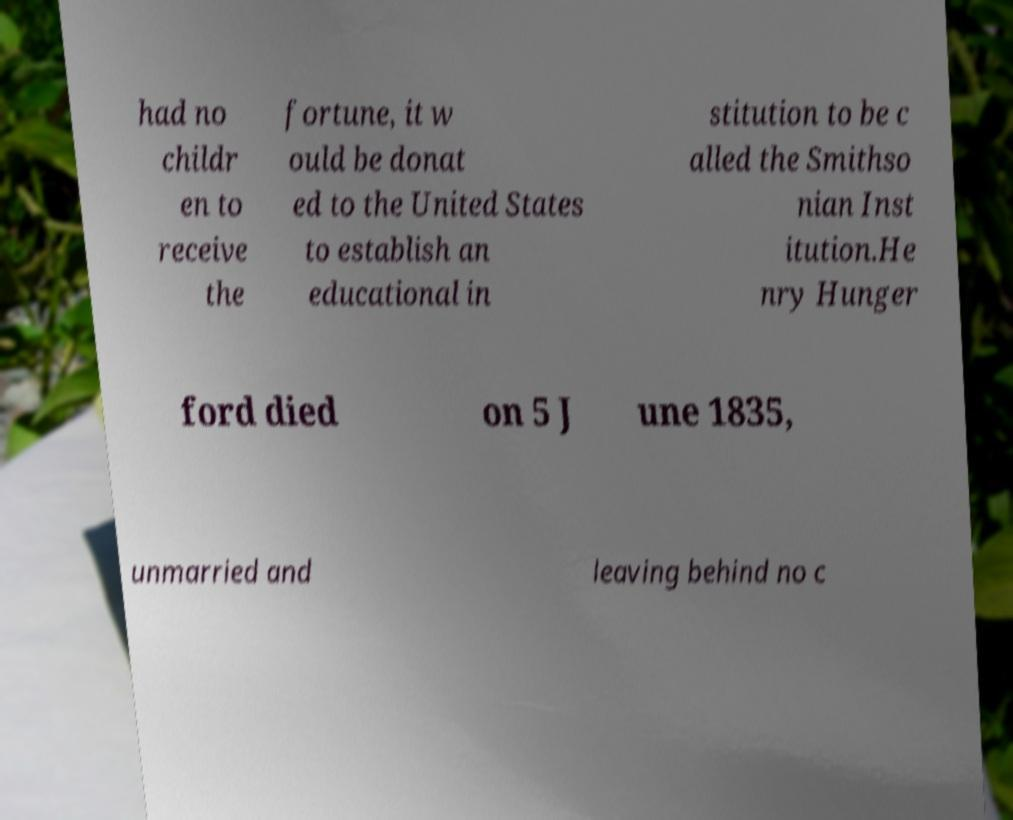Please read and relay the text visible in this image. What does it say? had no childr en to receive the fortune, it w ould be donat ed to the United States to establish an educational in stitution to be c alled the Smithso nian Inst itution.He nry Hunger ford died on 5 J une 1835, unmarried and leaving behind no c 